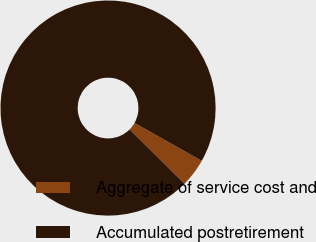<chart> <loc_0><loc_0><loc_500><loc_500><pie_chart><fcel>Aggregate of service cost and<fcel>Accumulated postretirement<nl><fcel>4.26%<fcel>95.74%<nl></chart> 